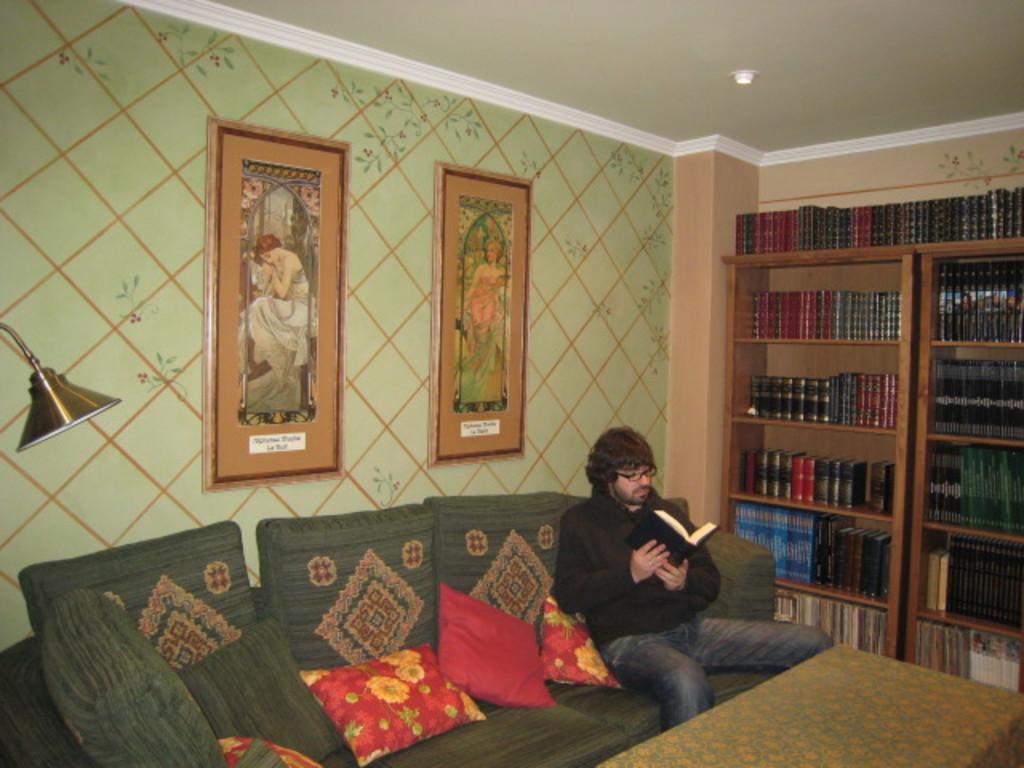In one or two sentences, can you explain what this image depicts? In this image I can see a person wearing black color dress is sitting on a couch which is green in color and holding a book in his hands. I can see few cushions which are red in color on the couch. In the background I can see the wall, few photo frames attached to the wall, a light, few bookshelves with books in them and the ceiling. I can see a table in front of the person. 